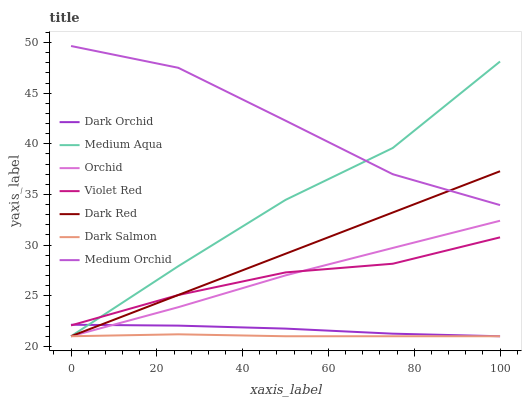Does Dark Red have the minimum area under the curve?
Answer yes or no. No. Does Dark Red have the maximum area under the curve?
Answer yes or no. No. Is Medium Orchid the smoothest?
Answer yes or no. No. Is Dark Red the roughest?
Answer yes or no. No. Does Medium Orchid have the lowest value?
Answer yes or no. No. Does Dark Red have the highest value?
Answer yes or no. No. Is Dark Salmon less than Medium Orchid?
Answer yes or no. Yes. Is Medium Orchid greater than Dark Salmon?
Answer yes or no. Yes. Does Dark Salmon intersect Medium Orchid?
Answer yes or no. No. 